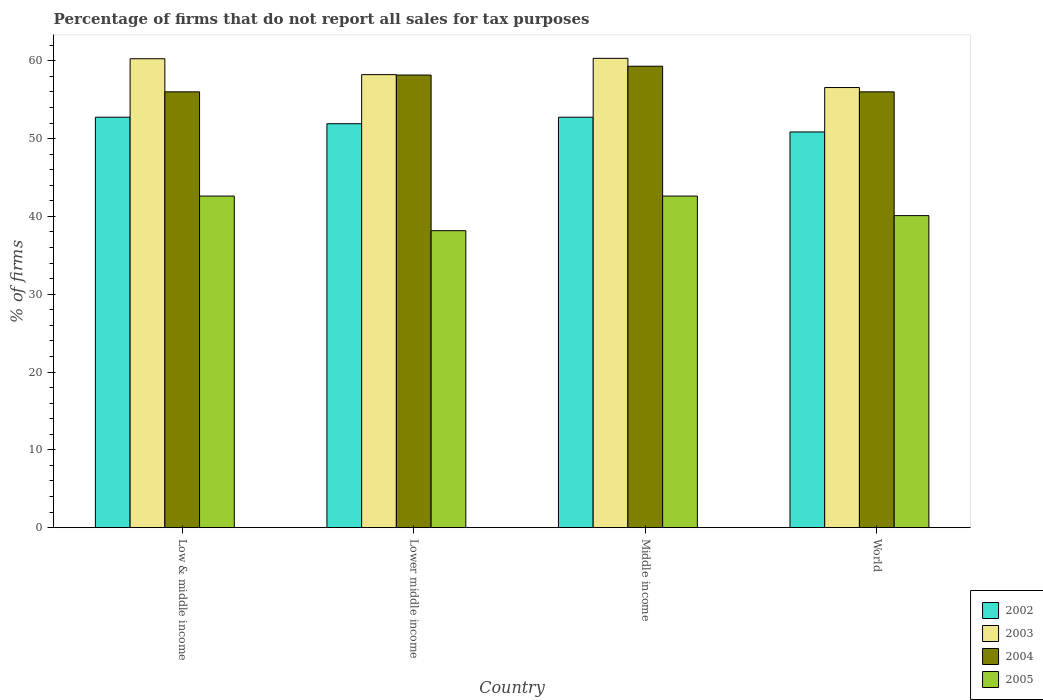How many different coloured bars are there?
Your response must be concise. 4. How many groups of bars are there?
Make the answer very short. 4. Are the number of bars on each tick of the X-axis equal?
Make the answer very short. Yes. How many bars are there on the 1st tick from the right?
Your answer should be very brief. 4. What is the label of the 3rd group of bars from the left?
Offer a very short reply. Middle income. In how many cases, is the number of bars for a given country not equal to the number of legend labels?
Provide a succinct answer. 0. What is the percentage of firms that do not report all sales for tax purposes in 2004 in World?
Ensure brevity in your answer.  56.01. Across all countries, what is the maximum percentage of firms that do not report all sales for tax purposes in 2005?
Your answer should be compact. 42.61. Across all countries, what is the minimum percentage of firms that do not report all sales for tax purposes in 2005?
Your answer should be compact. 38.16. What is the total percentage of firms that do not report all sales for tax purposes in 2004 in the graph?
Ensure brevity in your answer.  229.47. What is the difference between the percentage of firms that do not report all sales for tax purposes in 2002 in Low & middle income and that in World?
Keep it short and to the point. 1.89. What is the difference between the percentage of firms that do not report all sales for tax purposes in 2005 in Low & middle income and the percentage of firms that do not report all sales for tax purposes in 2002 in Middle income?
Your response must be concise. -10.13. What is the average percentage of firms that do not report all sales for tax purposes in 2003 per country?
Make the answer very short. 58.84. What is the difference between the percentage of firms that do not report all sales for tax purposes of/in 2005 and percentage of firms that do not report all sales for tax purposes of/in 2004 in Low & middle income?
Keep it short and to the point. -13.39. In how many countries, is the percentage of firms that do not report all sales for tax purposes in 2004 greater than 38 %?
Your response must be concise. 4. What is the ratio of the percentage of firms that do not report all sales for tax purposes in 2004 in Lower middle income to that in World?
Your answer should be very brief. 1.04. What is the difference between the highest and the second highest percentage of firms that do not report all sales for tax purposes in 2004?
Give a very brief answer. -2.16. What is the difference between the highest and the lowest percentage of firms that do not report all sales for tax purposes in 2003?
Ensure brevity in your answer.  3.75. In how many countries, is the percentage of firms that do not report all sales for tax purposes in 2005 greater than the average percentage of firms that do not report all sales for tax purposes in 2005 taken over all countries?
Provide a short and direct response. 2. Is it the case that in every country, the sum of the percentage of firms that do not report all sales for tax purposes in 2004 and percentage of firms that do not report all sales for tax purposes in 2002 is greater than the sum of percentage of firms that do not report all sales for tax purposes in 2003 and percentage of firms that do not report all sales for tax purposes in 2005?
Your answer should be very brief. No. What does the 4th bar from the right in Low & middle income represents?
Your response must be concise. 2002. Are all the bars in the graph horizontal?
Make the answer very short. No. How many countries are there in the graph?
Keep it short and to the point. 4. What is the difference between two consecutive major ticks on the Y-axis?
Keep it short and to the point. 10. Are the values on the major ticks of Y-axis written in scientific E-notation?
Keep it short and to the point. No. Where does the legend appear in the graph?
Ensure brevity in your answer.  Bottom right. How are the legend labels stacked?
Your answer should be compact. Vertical. What is the title of the graph?
Offer a very short reply. Percentage of firms that do not report all sales for tax purposes. What is the label or title of the Y-axis?
Keep it short and to the point. % of firms. What is the % of firms in 2002 in Low & middle income?
Provide a short and direct response. 52.75. What is the % of firms of 2003 in Low & middle income?
Keep it short and to the point. 60.26. What is the % of firms in 2004 in Low & middle income?
Keep it short and to the point. 56.01. What is the % of firms in 2005 in Low & middle income?
Your answer should be very brief. 42.61. What is the % of firms of 2002 in Lower middle income?
Provide a short and direct response. 51.91. What is the % of firms in 2003 in Lower middle income?
Offer a terse response. 58.22. What is the % of firms in 2004 in Lower middle income?
Provide a short and direct response. 58.16. What is the % of firms of 2005 in Lower middle income?
Offer a very short reply. 38.16. What is the % of firms of 2002 in Middle income?
Offer a terse response. 52.75. What is the % of firms of 2003 in Middle income?
Provide a short and direct response. 60.31. What is the % of firms of 2004 in Middle income?
Provide a succinct answer. 59.3. What is the % of firms in 2005 in Middle income?
Your answer should be very brief. 42.61. What is the % of firms of 2002 in World?
Keep it short and to the point. 50.85. What is the % of firms of 2003 in World?
Your answer should be very brief. 56.56. What is the % of firms of 2004 in World?
Offer a very short reply. 56.01. What is the % of firms in 2005 in World?
Make the answer very short. 40.1. Across all countries, what is the maximum % of firms in 2002?
Keep it short and to the point. 52.75. Across all countries, what is the maximum % of firms in 2003?
Offer a very short reply. 60.31. Across all countries, what is the maximum % of firms of 2004?
Make the answer very short. 59.3. Across all countries, what is the maximum % of firms in 2005?
Offer a very short reply. 42.61. Across all countries, what is the minimum % of firms of 2002?
Keep it short and to the point. 50.85. Across all countries, what is the minimum % of firms of 2003?
Your answer should be very brief. 56.56. Across all countries, what is the minimum % of firms of 2004?
Keep it short and to the point. 56.01. Across all countries, what is the minimum % of firms of 2005?
Make the answer very short. 38.16. What is the total % of firms in 2002 in the graph?
Give a very brief answer. 208.25. What is the total % of firms in 2003 in the graph?
Make the answer very short. 235.35. What is the total % of firms of 2004 in the graph?
Give a very brief answer. 229.47. What is the total % of firms of 2005 in the graph?
Offer a very short reply. 163.48. What is the difference between the % of firms in 2002 in Low & middle income and that in Lower middle income?
Your response must be concise. 0.84. What is the difference between the % of firms in 2003 in Low & middle income and that in Lower middle income?
Your answer should be compact. 2.04. What is the difference between the % of firms in 2004 in Low & middle income and that in Lower middle income?
Keep it short and to the point. -2.16. What is the difference between the % of firms of 2005 in Low & middle income and that in Lower middle income?
Provide a succinct answer. 4.45. What is the difference between the % of firms of 2003 in Low & middle income and that in Middle income?
Ensure brevity in your answer.  -0.05. What is the difference between the % of firms in 2004 in Low & middle income and that in Middle income?
Your answer should be very brief. -3.29. What is the difference between the % of firms of 2005 in Low & middle income and that in Middle income?
Provide a short and direct response. 0. What is the difference between the % of firms in 2002 in Low & middle income and that in World?
Make the answer very short. 1.89. What is the difference between the % of firms in 2003 in Low & middle income and that in World?
Ensure brevity in your answer.  3.7. What is the difference between the % of firms of 2004 in Low & middle income and that in World?
Make the answer very short. 0. What is the difference between the % of firms in 2005 in Low & middle income and that in World?
Your response must be concise. 2.51. What is the difference between the % of firms of 2002 in Lower middle income and that in Middle income?
Give a very brief answer. -0.84. What is the difference between the % of firms in 2003 in Lower middle income and that in Middle income?
Keep it short and to the point. -2.09. What is the difference between the % of firms in 2004 in Lower middle income and that in Middle income?
Your response must be concise. -1.13. What is the difference between the % of firms of 2005 in Lower middle income and that in Middle income?
Offer a terse response. -4.45. What is the difference between the % of firms of 2002 in Lower middle income and that in World?
Your answer should be compact. 1.06. What is the difference between the % of firms of 2003 in Lower middle income and that in World?
Give a very brief answer. 1.66. What is the difference between the % of firms in 2004 in Lower middle income and that in World?
Offer a terse response. 2.16. What is the difference between the % of firms in 2005 in Lower middle income and that in World?
Your answer should be very brief. -1.94. What is the difference between the % of firms in 2002 in Middle income and that in World?
Your response must be concise. 1.89. What is the difference between the % of firms of 2003 in Middle income and that in World?
Offer a terse response. 3.75. What is the difference between the % of firms in 2004 in Middle income and that in World?
Ensure brevity in your answer.  3.29. What is the difference between the % of firms of 2005 in Middle income and that in World?
Offer a terse response. 2.51. What is the difference between the % of firms of 2002 in Low & middle income and the % of firms of 2003 in Lower middle income?
Ensure brevity in your answer.  -5.47. What is the difference between the % of firms in 2002 in Low & middle income and the % of firms in 2004 in Lower middle income?
Ensure brevity in your answer.  -5.42. What is the difference between the % of firms of 2002 in Low & middle income and the % of firms of 2005 in Lower middle income?
Your response must be concise. 14.58. What is the difference between the % of firms of 2003 in Low & middle income and the % of firms of 2004 in Lower middle income?
Ensure brevity in your answer.  2.1. What is the difference between the % of firms in 2003 in Low & middle income and the % of firms in 2005 in Lower middle income?
Your answer should be very brief. 22.1. What is the difference between the % of firms of 2004 in Low & middle income and the % of firms of 2005 in Lower middle income?
Provide a succinct answer. 17.84. What is the difference between the % of firms in 2002 in Low & middle income and the % of firms in 2003 in Middle income?
Your answer should be very brief. -7.57. What is the difference between the % of firms in 2002 in Low & middle income and the % of firms in 2004 in Middle income?
Your response must be concise. -6.55. What is the difference between the % of firms in 2002 in Low & middle income and the % of firms in 2005 in Middle income?
Keep it short and to the point. 10.13. What is the difference between the % of firms in 2003 in Low & middle income and the % of firms in 2004 in Middle income?
Provide a succinct answer. 0.96. What is the difference between the % of firms in 2003 in Low & middle income and the % of firms in 2005 in Middle income?
Your answer should be very brief. 17.65. What is the difference between the % of firms of 2004 in Low & middle income and the % of firms of 2005 in Middle income?
Your response must be concise. 13.39. What is the difference between the % of firms of 2002 in Low & middle income and the % of firms of 2003 in World?
Give a very brief answer. -3.81. What is the difference between the % of firms in 2002 in Low & middle income and the % of firms in 2004 in World?
Offer a very short reply. -3.26. What is the difference between the % of firms of 2002 in Low & middle income and the % of firms of 2005 in World?
Keep it short and to the point. 12.65. What is the difference between the % of firms of 2003 in Low & middle income and the % of firms of 2004 in World?
Offer a very short reply. 4.25. What is the difference between the % of firms in 2003 in Low & middle income and the % of firms in 2005 in World?
Your response must be concise. 20.16. What is the difference between the % of firms of 2004 in Low & middle income and the % of firms of 2005 in World?
Your answer should be very brief. 15.91. What is the difference between the % of firms in 2002 in Lower middle income and the % of firms in 2003 in Middle income?
Keep it short and to the point. -8.4. What is the difference between the % of firms in 2002 in Lower middle income and the % of firms in 2004 in Middle income?
Make the answer very short. -7.39. What is the difference between the % of firms of 2002 in Lower middle income and the % of firms of 2005 in Middle income?
Offer a very short reply. 9.3. What is the difference between the % of firms in 2003 in Lower middle income and the % of firms in 2004 in Middle income?
Your response must be concise. -1.08. What is the difference between the % of firms of 2003 in Lower middle income and the % of firms of 2005 in Middle income?
Ensure brevity in your answer.  15.61. What is the difference between the % of firms in 2004 in Lower middle income and the % of firms in 2005 in Middle income?
Make the answer very short. 15.55. What is the difference between the % of firms of 2002 in Lower middle income and the % of firms of 2003 in World?
Provide a short and direct response. -4.65. What is the difference between the % of firms of 2002 in Lower middle income and the % of firms of 2004 in World?
Offer a terse response. -4.1. What is the difference between the % of firms of 2002 in Lower middle income and the % of firms of 2005 in World?
Offer a terse response. 11.81. What is the difference between the % of firms in 2003 in Lower middle income and the % of firms in 2004 in World?
Give a very brief answer. 2.21. What is the difference between the % of firms in 2003 in Lower middle income and the % of firms in 2005 in World?
Provide a short and direct response. 18.12. What is the difference between the % of firms in 2004 in Lower middle income and the % of firms in 2005 in World?
Your response must be concise. 18.07. What is the difference between the % of firms of 2002 in Middle income and the % of firms of 2003 in World?
Give a very brief answer. -3.81. What is the difference between the % of firms of 2002 in Middle income and the % of firms of 2004 in World?
Provide a succinct answer. -3.26. What is the difference between the % of firms of 2002 in Middle income and the % of firms of 2005 in World?
Offer a terse response. 12.65. What is the difference between the % of firms of 2003 in Middle income and the % of firms of 2004 in World?
Your answer should be very brief. 4.31. What is the difference between the % of firms of 2003 in Middle income and the % of firms of 2005 in World?
Provide a short and direct response. 20.21. What is the difference between the % of firms in 2004 in Middle income and the % of firms in 2005 in World?
Make the answer very short. 19.2. What is the average % of firms in 2002 per country?
Your answer should be very brief. 52.06. What is the average % of firms of 2003 per country?
Offer a terse response. 58.84. What is the average % of firms of 2004 per country?
Offer a terse response. 57.37. What is the average % of firms in 2005 per country?
Make the answer very short. 40.87. What is the difference between the % of firms of 2002 and % of firms of 2003 in Low & middle income?
Your answer should be very brief. -7.51. What is the difference between the % of firms in 2002 and % of firms in 2004 in Low & middle income?
Provide a succinct answer. -3.26. What is the difference between the % of firms of 2002 and % of firms of 2005 in Low & middle income?
Your response must be concise. 10.13. What is the difference between the % of firms in 2003 and % of firms in 2004 in Low & middle income?
Give a very brief answer. 4.25. What is the difference between the % of firms in 2003 and % of firms in 2005 in Low & middle income?
Your answer should be compact. 17.65. What is the difference between the % of firms in 2004 and % of firms in 2005 in Low & middle income?
Ensure brevity in your answer.  13.39. What is the difference between the % of firms in 2002 and % of firms in 2003 in Lower middle income?
Your answer should be very brief. -6.31. What is the difference between the % of firms in 2002 and % of firms in 2004 in Lower middle income?
Your response must be concise. -6.26. What is the difference between the % of firms in 2002 and % of firms in 2005 in Lower middle income?
Offer a very short reply. 13.75. What is the difference between the % of firms in 2003 and % of firms in 2004 in Lower middle income?
Ensure brevity in your answer.  0.05. What is the difference between the % of firms of 2003 and % of firms of 2005 in Lower middle income?
Your response must be concise. 20.06. What is the difference between the % of firms in 2004 and % of firms in 2005 in Lower middle income?
Provide a short and direct response. 20. What is the difference between the % of firms in 2002 and % of firms in 2003 in Middle income?
Offer a terse response. -7.57. What is the difference between the % of firms of 2002 and % of firms of 2004 in Middle income?
Your answer should be compact. -6.55. What is the difference between the % of firms of 2002 and % of firms of 2005 in Middle income?
Your answer should be compact. 10.13. What is the difference between the % of firms in 2003 and % of firms in 2004 in Middle income?
Your response must be concise. 1.02. What is the difference between the % of firms in 2003 and % of firms in 2005 in Middle income?
Ensure brevity in your answer.  17.7. What is the difference between the % of firms in 2004 and % of firms in 2005 in Middle income?
Your response must be concise. 16.69. What is the difference between the % of firms of 2002 and % of firms of 2003 in World?
Make the answer very short. -5.71. What is the difference between the % of firms in 2002 and % of firms in 2004 in World?
Your response must be concise. -5.15. What is the difference between the % of firms of 2002 and % of firms of 2005 in World?
Your response must be concise. 10.75. What is the difference between the % of firms of 2003 and % of firms of 2004 in World?
Your answer should be compact. 0.56. What is the difference between the % of firms in 2003 and % of firms in 2005 in World?
Offer a very short reply. 16.46. What is the difference between the % of firms in 2004 and % of firms in 2005 in World?
Your answer should be compact. 15.91. What is the ratio of the % of firms in 2002 in Low & middle income to that in Lower middle income?
Keep it short and to the point. 1.02. What is the ratio of the % of firms in 2003 in Low & middle income to that in Lower middle income?
Keep it short and to the point. 1.04. What is the ratio of the % of firms in 2004 in Low & middle income to that in Lower middle income?
Make the answer very short. 0.96. What is the ratio of the % of firms of 2005 in Low & middle income to that in Lower middle income?
Your answer should be compact. 1.12. What is the ratio of the % of firms in 2002 in Low & middle income to that in Middle income?
Your answer should be compact. 1. What is the ratio of the % of firms in 2004 in Low & middle income to that in Middle income?
Your response must be concise. 0.94. What is the ratio of the % of firms in 2002 in Low & middle income to that in World?
Give a very brief answer. 1.04. What is the ratio of the % of firms in 2003 in Low & middle income to that in World?
Provide a succinct answer. 1.07. What is the ratio of the % of firms in 2004 in Low & middle income to that in World?
Your answer should be compact. 1. What is the ratio of the % of firms in 2005 in Low & middle income to that in World?
Keep it short and to the point. 1.06. What is the ratio of the % of firms of 2002 in Lower middle income to that in Middle income?
Your answer should be compact. 0.98. What is the ratio of the % of firms in 2003 in Lower middle income to that in Middle income?
Offer a very short reply. 0.97. What is the ratio of the % of firms in 2004 in Lower middle income to that in Middle income?
Offer a terse response. 0.98. What is the ratio of the % of firms in 2005 in Lower middle income to that in Middle income?
Make the answer very short. 0.9. What is the ratio of the % of firms of 2002 in Lower middle income to that in World?
Your answer should be compact. 1.02. What is the ratio of the % of firms in 2003 in Lower middle income to that in World?
Your response must be concise. 1.03. What is the ratio of the % of firms of 2004 in Lower middle income to that in World?
Your answer should be compact. 1.04. What is the ratio of the % of firms of 2005 in Lower middle income to that in World?
Give a very brief answer. 0.95. What is the ratio of the % of firms in 2002 in Middle income to that in World?
Make the answer very short. 1.04. What is the ratio of the % of firms in 2003 in Middle income to that in World?
Keep it short and to the point. 1.07. What is the ratio of the % of firms of 2004 in Middle income to that in World?
Keep it short and to the point. 1.06. What is the ratio of the % of firms of 2005 in Middle income to that in World?
Keep it short and to the point. 1.06. What is the difference between the highest and the second highest % of firms in 2002?
Provide a succinct answer. 0. What is the difference between the highest and the second highest % of firms in 2003?
Your response must be concise. 0.05. What is the difference between the highest and the second highest % of firms of 2004?
Give a very brief answer. 1.13. What is the difference between the highest and the lowest % of firms in 2002?
Provide a short and direct response. 1.89. What is the difference between the highest and the lowest % of firms in 2003?
Provide a short and direct response. 3.75. What is the difference between the highest and the lowest % of firms of 2004?
Ensure brevity in your answer.  3.29. What is the difference between the highest and the lowest % of firms of 2005?
Give a very brief answer. 4.45. 